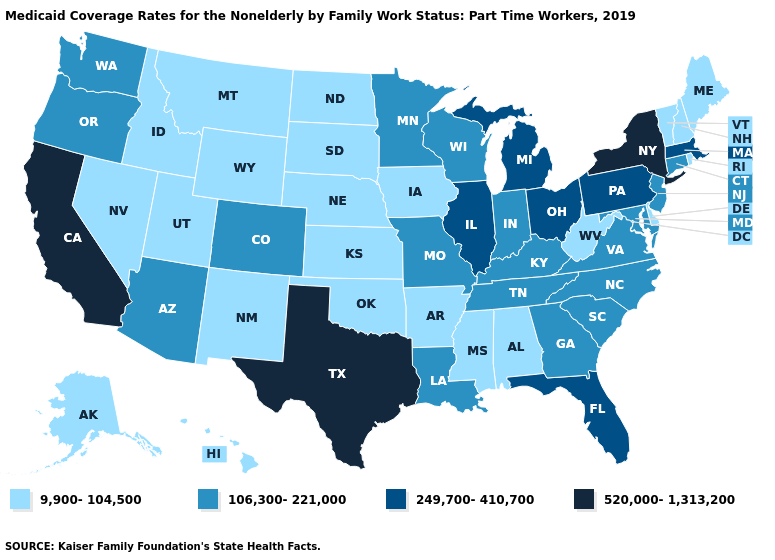Does Texas have the highest value in the USA?
Be succinct. Yes. What is the lowest value in states that border Georgia?
Write a very short answer. 9,900-104,500. Name the states that have a value in the range 520,000-1,313,200?
Answer briefly. California, New York, Texas. Which states have the lowest value in the USA?
Keep it brief. Alabama, Alaska, Arkansas, Delaware, Hawaii, Idaho, Iowa, Kansas, Maine, Mississippi, Montana, Nebraska, Nevada, New Hampshire, New Mexico, North Dakota, Oklahoma, Rhode Island, South Dakota, Utah, Vermont, West Virginia, Wyoming. What is the highest value in the USA?
Quick response, please. 520,000-1,313,200. Among the states that border Kansas , which have the lowest value?
Be succinct. Nebraska, Oklahoma. Name the states that have a value in the range 249,700-410,700?
Keep it brief. Florida, Illinois, Massachusetts, Michigan, Ohio, Pennsylvania. What is the highest value in states that border Wisconsin?
Write a very short answer. 249,700-410,700. Name the states that have a value in the range 520,000-1,313,200?
Answer briefly. California, New York, Texas. What is the highest value in the USA?
Concise answer only. 520,000-1,313,200. Among the states that border Mississippi , does Alabama have the lowest value?
Quick response, please. Yes. What is the value of Wyoming?
Concise answer only. 9,900-104,500. What is the value of Wyoming?
Answer briefly. 9,900-104,500. Does New Mexico have a lower value than Nevada?
Answer briefly. No. Does the map have missing data?
Keep it brief. No. 